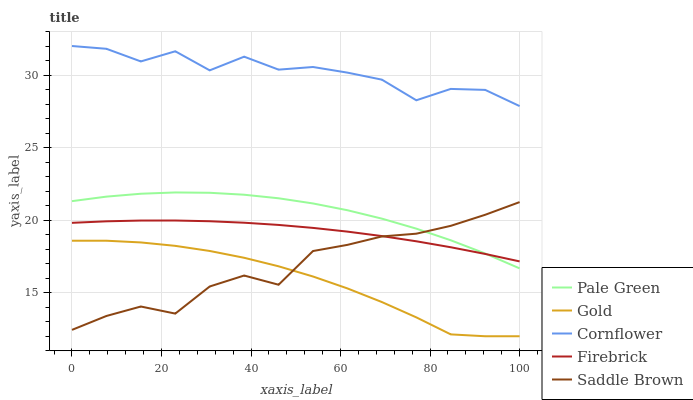Does Gold have the minimum area under the curve?
Answer yes or no. Yes. Does Cornflower have the maximum area under the curve?
Answer yes or no. Yes. Does Firebrick have the minimum area under the curve?
Answer yes or no. No. Does Firebrick have the maximum area under the curve?
Answer yes or no. No. Is Firebrick the smoothest?
Answer yes or no. Yes. Is Cornflower the roughest?
Answer yes or no. Yes. Is Pale Green the smoothest?
Answer yes or no. No. Is Pale Green the roughest?
Answer yes or no. No. Does Gold have the lowest value?
Answer yes or no. Yes. Does Firebrick have the lowest value?
Answer yes or no. No. Does Cornflower have the highest value?
Answer yes or no. Yes. Does Firebrick have the highest value?
Answer yes or no. No. Is Saddle Brown less than Cornflower?
Answer yes or no. Yes. Is Cornflower greater than Pale Green?
Answer yes or no. Yes. Does Saddle Brown intersect Firebrick?
Answer yes or no. Yes. Is Saddle Brown less than Firebrick?
Answer yes or no. No. Is Saddle Brown greater than Firebrick?
Answer yes or no. No. Does Saddle Brown intersect Cornflower?
Answer yes or no. No. 